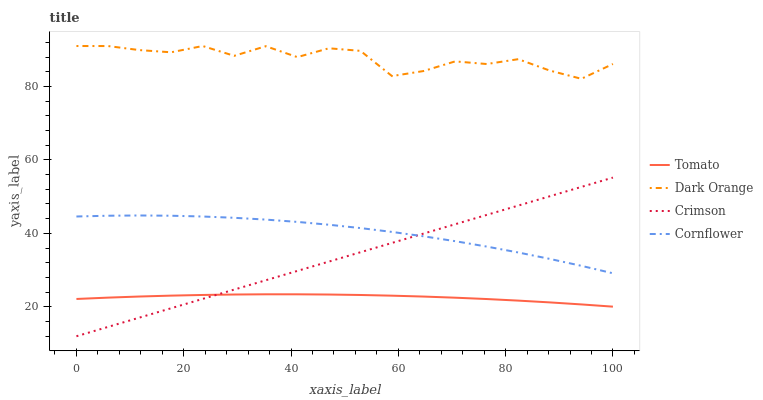Does Crimson have the minimum area under the curve?
Answer yes or no. No. Does Crimson have the maximum area under the curve?
Answer yes or no. No. Is Dark Orange the smoothest?
Answer yes or no. No. Is Crimson the roughest?
Answer yes or no. No. Does Dark Orange have the lowest value?
Answer yes or no. No. Does Crimson have the highest value?
Answer yes or no. No. Is Tomato less than Cornflower?
Answer yes or no. Yes. Is Cornflower greater than Tomato?
Answer yes or no. Yes. Does Tomato intersect Cornflower?
Answer yes or no. No. 